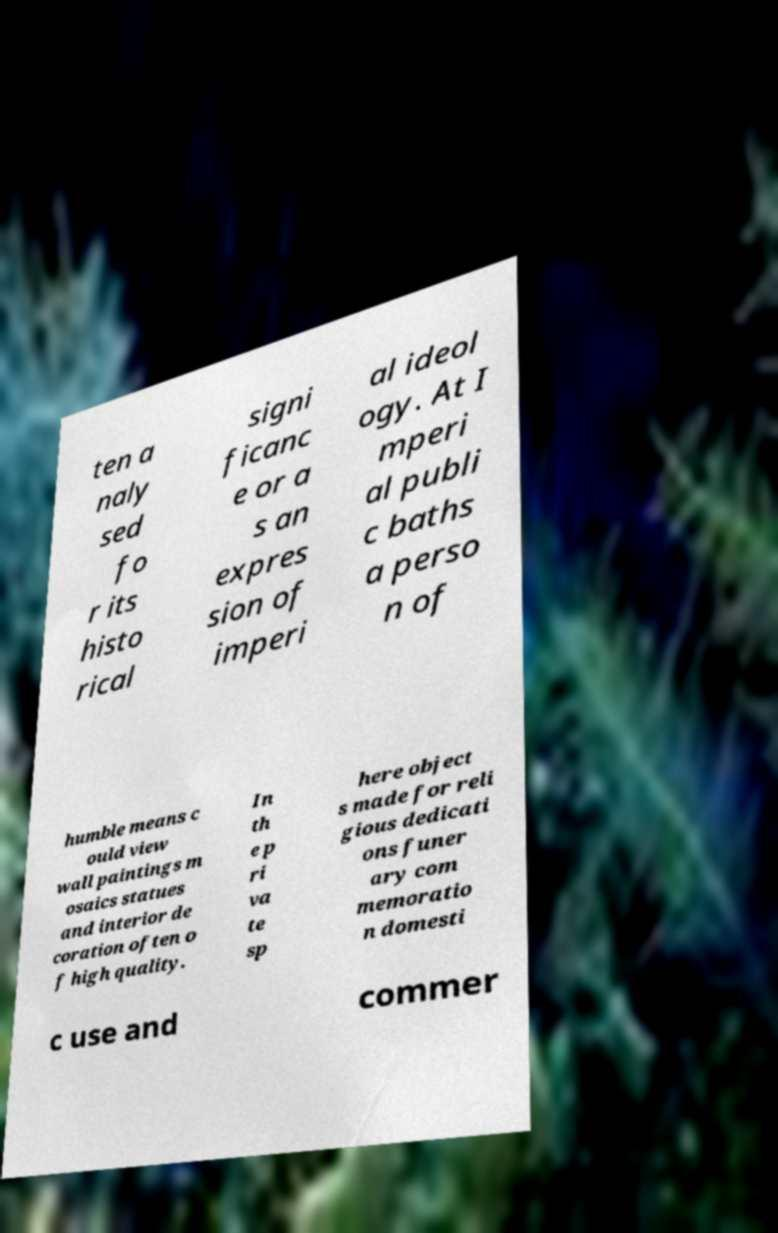Can you accurately transcribe the text from the provided image for me? ten a naly sed fo r its histo rical signi ficanc e or a s an expres sion of imperi al ideol ogy. At I mperi al publi c baths a perso n of humble means c ould view wall paintings m osaics statues and interior de coration often o f high quality. In th e p ri va te sp here object s made for reli gious dedicati ons funer ary com memoratio n domesti c use and commer 